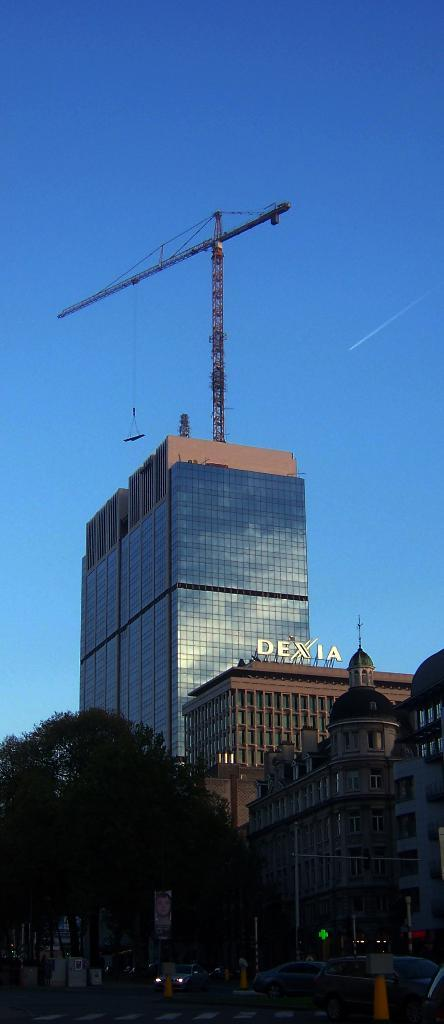What is located in the foreground of the image? There is a tree and buildings in the foreground of the image. What is happening on the road in the image? Vehicles are moving on the road in the image. What can be seen on one of the buildings in the image? There is a crane on a building in the image. What part of the natural environment is visible in the image? The sky is visible in the image. What type of drink is being consumed by the tree in the image? There is no drink being consumed by the tree in the image, as trees do not consume drinks. What is the memory capacity of the crane on the building in the image? There is no memory capacity associated with the crane on the building in the image, as it is a construction crane and not a device with memory. 